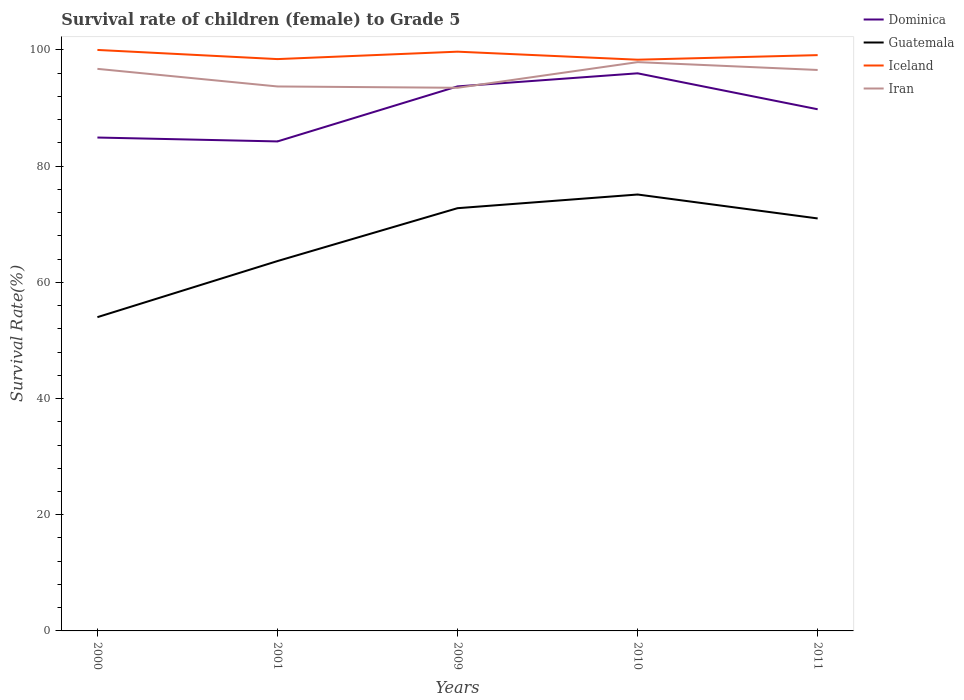Does the line corresponding to Guatemala intersect with the line corresponding to Iceland?
Keep it short and to the point. No. Across all years, what is the maximum survival rate of female children to grade 5 in Dominica?
Your answer should be very brief. 84.25. What is the total survival rate of female children to grade 5 in Iceland in the graph?
Offer a terse response. 0.3. What is the difference between the highest and the second highest survival rate of female children to grade 5 in Iceland?
Keep it short and to the point. 1.68. Is the survival rate of female children to grade 5 in Iran strictly greater than the survival rate of female children to grade 5 in Iceland over the years?
Your answer should be compact. Yes. What is the difference between two consecutive major ticks on the Y-axis?
Offer a terse response. 20. Does the graph contain any zero values?
Provide a succinct answer. No. Where does the legend appear in the graph?
Offer a very short reply. Top right. What is the title of the graph?
Your answer should be compact. Survival rate of children (female) to Grade 5. What is the label or title of the Y-axis?
Your response must be concise. Survival Rate(%). What is the Survival Rate(%) of Dominica in 2000?
Your answer should be very brief. 84.92. What is the Survival Rate(%) of Guatemala in 2000?
Your response must be concise. 54. What is the Survival Rate(%) in Iran in 2000?
Your response must be concise. 96.74. What is the Survival Rate(%) in Dominica in 2001?
Your answer should be very brief. 84.25. What is the Survival Rate(%) in Guatemala in 2001?
Keep it short and to the point. 63.66. What is the Survival Rate(%) in Iceland in 2001?
Your response must be concise. 98.42. What is the Survival Rate(%) in Iran in 2001?
Your answer should be very brief. 93.71. What is the Survival Rate(%) of Dominica in 2009?
Offer a terse response. 93.72. What is the Survival Rate(%) of Guatemala in 2009?
Make the answer very short. 72.76. What is the Survival Rate(%) of Iceland in 2009?
Ensure brevity in your answer.  99.7. What is the Survival Rate(%) in Iran in 2009?
Provide a short and direct response. 93.49. What is the Survival Rate(%) in Dominica in 2010?
Your response must be concise. 95.98. What is the Survival Rate(%) of Guatemala in 2010?
Offer a very short reply. 75.12. What is the Survival Rate(%) of Iceland in 2010?
Offer a very short reply. 98.32. What is the Survival Rate(%) in Iran in 2010?
Offer a terse response. 97.9. What is the Survival Rate(%) in Dominica in 2011?
Provide a short and direct response. 89.79. What is the Survival Rate(%) of Guatemala in 2011?
Keep it short and to the point. 71. What is the Survival Rate(%) of Iceland in 2011?
Ensure brevity in your answer.  99.11. What is the Survival Rate(%) in Iran in 2011?
Offer a terse response. 96.55. Across all years, what is the maximum Survival Rate(%) in Dominica?
Offer a very short reply. 95.98. Across all years, what is the maximum Survival Rate(%) of Guatemala?
Give a very brief answer. 75.12. Across all years, what is the maximum Survival Rate(%) of Iran?
Ensure brevity in your answer.  97.9. Across all years, what is the minimum Survival Rate(%) of Dominica?
Give a very brief answer. 84.25. Across all years, what is the minimum Survival Rate(%) of Guatemala?
Keep it short and to the point. 54. Across all years, what is the minimum Survival Rate(%) of Iceland?
Your answer should be very brief. 98.32. Across all years, what is the minimum Survival Rate(%) of Iran?
Give a very brief answer. 93.49. What is the total Survival Rate(%) in Dominica in the graph?
Provide a succinct answer. 448.66. What is the total Survival Rate(%) of Guatemala in the graph?
Your answer should be compact. 336.54. What is the total Survival Rate(%) in Iceland in the graph?
Ensure brevity in your answer.  495.55. What is the total Survival Rate(%) in Iran in the graph?
Keep it short and to the point. 478.4. What is the difference between the Survival Rate(%) in Dominica in 2000 and that in 2001?
Provide a succinct answer. 0.67. What is the difference between the Survival Rate(%) in Guatemala in 2000 and that in 2001?
Your response must be concise. -9.66. What is the difference between the Survival Rate(%) in Iceland in 2000 and that in 2001?
Keep it short and to the point. 1.58. What is the difference between the Survival Rate(%) of Iran in 2000 and that in 2001?
Offer a terse response. 3.03. What is the difference between the Survival Rate(%) in Dominica in 2000 and that in 2009?
Provide a succinct answer. -8.8. What is the difference between the Survival Rate(%) in Guatemala in 2000 and that in 2009?
Give a very brief answer. -18.76. What is the difference between the Survival Rate(%) in Iceland in 2000 and that in 2009?
Your answer should be very brief. 0.3. What is the difference between the Survival Rate(%) in Iran in 2000 and that in 2009?
Provide a succinct answer. 3.26. What is the difference between the Survival Rate(%) of Dominica in 2000 and that in 2010?
Provide a short and direct response. -11.05. What is the difference between the Survival Rate(%) of Guatemala in 2000 and that in 2010?
Your response must be concise. -21.11. What is the difference between the Survival Rate(%) of Iceland in 2000 and that in 2010?
Your answer should be compact. 1.68. What is the difference between the Survival Rate(%) of Iran in 2000 and that in 2010?
Offer a very short reply. -1.16. What is the difference between the Survival Rate(%) of Dominica in 2000 and that in 2011?
Ensure brevity in your answer.  -4.86. What is the difference between the Survival Rate(%) in Guatemala in 2000 and that in 2011?
Provide a succinct answer. -16.99. What is the difference between the Survival Rate(%) of Iceland in 2000 and that in 2011?
Ensure brevity in your answer.  0.89. What is the difference between the Survival Rate(%) of Iran in 2000 and that in 2011?
Provide a succinct answer. 0.19. What is the difference between the Survival Rate(%) of Dominica in 2001 and that in 2009?
Your response must be concise. -9.47. What is the difference between the Survival Rate(%) of Guatemala in 2001 and that in 2009?
Offer a very short reply. -9.1. What is the difference between the Survival Rate(%) of Iceland in 2001 and that in 2009?
Offer a very short reply. -1.28. What is the difference between the Survival Rate(%) of Iran in 2001 and that in 2009?
Make the answer very short. 0.23. What is the difference between the Survival Rate(%) in Dominica in 2001 and that in 2010?
Your answer should be very brief. -11.72. What is the difference between the Survival Rate(%) of Guatemala in 2001 and that in 2010?
Ensure brevity in your answer.  -11.45. What is the difference between the Survival Rate(%) in Iceland in 2001 and that in 2010?
Keep it short and to the point. 0.1. What is the difference between the Survival Rate(%) in Iran in 2001 and that in 2010?
Your answer should be very brief. -4.19. What is the difference between the Survival Rate(%) in Dominica in 2001 and that in 2011?
Provide a succinct answer. -5.54. What is the difference between the Survival Rate(%) in Guatemala in 2001 and that in 2011?
Provide a succinct answer. -7.34. What is the difference between the Survival Rate(%) of Iceland in 2001 and that in 2011?
Provide a succinct answer. -0.68. What is the difference between the Survival Rate(%) in Iran in 2001 and that in 2011?
Provide a short and direct response. -2.84. What is the difference between the Survival Rate(%) of Dominica in 2009 and that in 2010?
Ensure brevity in your answer.  -2.25. What is the difference between the Survival Rate(%) of Guatemala in 2009 and that in 2010?
Your answer should be compact. -2.35. What is the difference between the Survival Rate(%) in Iceland in 2009 and that in 2010?
Give a very brief answer. 1.38. What is the difference between the Survival Rate(%) in Iran in 2009 and that in 2010?
Provide a short and direct response. -4.42. What is the difference between the Survival Rate(%) in Dominica in 2009 and that in 2011?
Make the answer very short. 3.94. What is the difference between the Survival Rate(%) in Guatemala in 2009 and that in 2011?
Ensure brevity in your answer.  1.77. What is the difference between the Survival Rate(%) of Iceland in 2009 and that in 2011?
Offer a very short reply. 0.6. What is the difference between the Survival Rate(%) of Iran in 2009 and that in 2011?
Offer a very short reply. -3.07. What is the difference between the Survival Rate(%) of Dominica in 2010 and that in 2011?
Make the answer very short. 6.19. What is the difference between the Survival Rate(%) in Guatemala in 2010 and that in 2011?
Your answer should be compact. 4.12. What is the difference between the Survival Rate(%) in Iceland in 2010 and that in 2011?
Your answer should be compact. -0.79. What is the difference between the Survival Rate(%) of Iran in 2010 and that in 2011?
Keep it short and to the point. 1.35. What is the difference between the Survival Rate(%) in Dominica in 2000 and the Survival Rate(%) in Guatemala in 2001?
Give a very brief answer. 21.26. What is the difference between the Survival Rate(%) of Dominica in 2000 and the Survival Rate(%) of Iceland in 2001?
Provide a short and direct response. -13.5. What is the difference between the Survival Rate(%) of Dominica in 2000 and the Survival Rate(%) of Iran in 2001?
Make the answer very short. -8.79. What is the difference between the Survival Rate(%) in Guatemala in 2000 and the Survival Rate(%) in Iceland in 2001?
Offer a very short reply. -44.42. What is the difference between the Survival Rate(%) in Guatemala in 2000 and the Survival Rate(%) in Iran in 2001?
Your answer should be compact. -39.71. What is the difference between the Survival Rate(%) in Iceland in 2000 and the Survival Rate(%) in Iran in 2001?
Provide a succinct answer. 6.29. What is the difference between the Survival Rate(%) in Dominica in 2000 and the Survival Rate(%) in Guatemala in 2009?
Your answer should be very brief. 12.16. What is the difference between the Survival Rate(%) in Dominica in 2000 and the Survival Rate(%) in Iceland in 2009?
Keep it short and to the point. -14.78. What is the difference between the Survival Rate(%) in Dominica in 2000 and the Survival Rate(%) in Iran in 2009?
Make the answer very short. -8.56. What is the difference between the Survival Rate(%) in Guatemala in 2000 and the Survival Rate(%) in Iceland in 2009?
Provide a short and direct response. -45.7. What is the difference between the Survival Rate(%) in Guatemala in 2000 and the Survival Rate(%) in Iran in 2009?
Offer a terse response. -39.48. What is the difference between the Survival Rate(%) in Iceland in 2000 and the Survival Rate(%) in Iran in 2009?
Give a very brief answer. 6.51. What is the difference between the Survival Rate(%) of Dominica in 2000 and the Survival Rate(%) of Guatemala in 2010?
Make the answer very short. 9.81. What is the difference between the Survival Rate(%) of Dominica in 2000 and the Survival Rate(%) of Iceland in 2010?
Your response must be concise. -13.39. What is the difference between the Survival Rate(%) of Dominica in 2000 and the Survival Rate(%) of Iran in 2010?
Keep it short and to the point. -12.98. What is the difference between the Survival Rate(%) of Guatemala in 2000 and the Survival Rate(%) of Iceland in 2010?
Your answer should be very brief. -44.31. What is the difference between the Survival Rate(%) of Guatemala in 2000 and the Survival Rate(%) of Iran in 2010?
Keep it short and to the point. -43.9. What is the difference between the Survival Rate(%) of Iceland in 2000 and the Survival Rate(%) of Iran in 2010?
Offer a very short reply. 2.1. What is the difference between the Survival Rate(%) of Dominica in 2000 and the Survival Rate(%) of Guatemala in 2011?
Your response must be concise. 13.93. What is the difference between the Survival Rate(%) in Dominica in 2000 and the Survival Rate(%) in Iceland in 2011?
Ensure brevity in your answer.  -14.18. What is the difference between the Survival Rate(%) of Dominica in 2000 and the Survival Rate(%) of Iran in 2011?
Ensure brevity in your answer.  -11.63. What is the difference between the Survival Rate(%) of Guatemala in 2000 and the Survival Rate(%) of Iceland in 2011?
Keep it short and to the point. -45.1. What is the difference between the Survival Rate(%) in Guatemala in 2000 and the Survival Rate(%) in Iran in 2011?
Your answer should be compact. -42.55. What is the difference between the Survival Rate(%) of Iceland in 2000 and the Survival Rate(%) of Iran in 2011?
Ensure brevity in your answer.  3.45. What is the difference between the Survival Rate(%) in Dominica in 2001 and the Survival Rate(%) in Guatemala in 2009?
Make the answer very short. 11.49. What is the difference between the Survival Rate(%) in Dominica in 2001 and the Survival Rate(%) in Iceland in 2009?
Offer a terse response. -15.45. What is the difference between the Survival Rate(%) of Dominica in 2001 and the Survival Rate(%) of Iran in 2009?
Give a very brief answer. -9.23. What is the difference between the Survival Rate(%) in Guatemala in 2001 and the Survival Rate(%) in Iceland in 2009?
Provide a succinct answer. -36.04. What is the difference between the Survival Rate(%) in Guatemala in 2001 and the Survival Rate(%) in Iran in 2009?
Your response must be concise. -29.82. What is the difference between the Survival Rate(%) of Iceland in 2001 and the Survival Rate(%) of Iran in 2009?
Offer a terse response. 4.94. What is the difference between the Survival Rate(%) of Dominica in 2001 and the Survival Rate(%) of Guatemala in 2010?
Ensure brevity in your answer.  9.14. What is the difference between the Survival Rate(%) in Dominica in 2001 and the Survival Rate(%) in Iceland in 2010?
Keep it short and to the point. -14.07. What is the difference between the Survival Rate(%) in Dominica in 2001 and the Survival Rate(%) in Iran in 2010?
Give a very brief answer. -13.65. What is the difference between the Survival Rate(%) in Guatemala in 2001 and the Survival Rate(%) in Iceland in 2010?
Offer a very short reply. -34.66. What is the difference between the Survival Rate(%) of Guatemala in 2001 and the Survival Rate(%) of Iran in 2010?
Give a very brief answer. -34.24. What is the difference between the Survival Rate(%) in Iceland in 2001 and the Survival Rate(%) in Iran in 2010?
Your response must be concise. 0.52. What is the difference between the Survival Rate(%) of Dominica in 2001 and the Survival Rate(%) of Guatemala in 2011?
Make the answer very short. 13.26. What is the difference between the Survival Rate(%) of Dominica in 2001 and the Survival Rate(%) of Iceland in 2011?
Your response must be concise. -14.85. What is the difference between the Survival Rate(%) of Dominica in 2001 and the Survival Rate(%) of Iran in 2011?
Ensure brevity in your answer.  -12.3. What is the difference between the Survival Rate(%) of Guatemala in 2001 and the Survival Rate(%) of Iceland in 2011?
Keep it short and to the point. -35.45. What is the difference between the Survival Rate(%) of Guatemala in 2001 and the Survival Rate(%) of Iran in 2011?
Your response must be concise. -32.89. What is the difference between the Survival Rate(%) in Iceland in 2001 and the Survival Rate(%) in Iran in 2011?
Ensure brevity in your answer.  1.87. What is the difference between the Survival Rate(%) of Dominica in 2009 and the Survival Rate(%) of Guatemala in 2010?
Give a very brief answer. 18.61. What is the difference between the Survival Rate(%) of Dominica in 2009 and the Survival Rate(%) of Iceland in 2010?
Make the answer very short. -4.6. What is the difference between the Survival Rate(%) in Dominica in 2009 and the Survival Rate(%) in Iran in 2010?
Your answer should be very brief. -4.18. What is the difference between the Survival Rate(%) in Guatemala in 2009 and the Survival Rate(%) in Iceland in 2010?
Provide a succinct answer. -25.56. What is the difference between the Survival Rate(%) in Guatemala in 2009 and the Survival Rate(%) in Iran in 2010?
Keep it short and to the point. -25.14. What is the difference between the Survival Rate(%) in Iceland in 2009 and the Survival Rate(%) in Iran in 2010?
Offer a very short reply. 1.8. What is the difference between the Survival Rate(%) of Dominica in 2009 and the Survival Rate(%) of Guatemala in 2011?
Give a very brief answer. 22.73. What is the difference between the Survival Rate(%) of Dominica in 2009 and the Survival Rate(%) of Iceland in 2011?
Offer a very short reply. -5.38. What is the difference between the Survival Rate(%) in Dominica in 2009 and the Survival Rate(%) in Iran in 2011?
Offer a very short reply. -2.83. What is the difference between the Survival Rate(%) in Guatemala in 2009 and the Survival Rate(%) in Iceland in 2011?
Offer a very short reply. -26.34. What is the difference between the Survival Rate(%) in Guatemala in 2009 and the Survival Rate(%) in Iran in 2011?
Offer a very short reply. -23.79. What is the difference between the Survival Rate(%) in Iceland in 2009 and the Survival Rate(%) in Iran in 2011?
Give a very brief answer. 3.15. What is the difference between the Survival Rate(%) in Dominica in 2010 and the Survival Rate(%) in Guatemala in 2011?
Ensure brevity in your answer.  24.98. What is the difference between the Survival Rate(%) in Dominica in 2010 and the Survival Rate(%) in Iceland in 2011?
Offer a very short reply. -3.13. What is the difference between the Survival Rate(%) of Dominica in 2010 and the Survival Rate(%) of Iran in 2011?
Your answer should be compact. -0.58. What is the difference between the Survival Rate(%) of Guatemala in 2010 and the Survival Rate(%) of Iceland in 2011?
Give a very brief answer. -23.99. What is the difference between the Survival Rate(%) of Guatemala in 2010 and the Survival Rate(%) of Iran in 2011?
Your answer should be very brief. -21.44. What is the difference between the Survival Rate(%) of Iceland in 2010 and the Survival Rate(%) of Iran in 2011?
Offer a terse response. 1.77. What is the average Survival Rate(%) in Dominica per year?
Make the answer very short. 89.73. What is the average Survival Rate(%) of Guatemala per year?
Ensure brevity in your answer.  67.31. What is the average Survival Rate(%) in Iceland per year?
Your answer should be very brief. 99.11. What is the average Survival Rate(%) in Iran per year?
Offer a very short reply. 95.68. In the year 2000, what is the difference between the Survival Rate(%) of Dominica and Survival Rate(%) of Guatemala?
Ensure brevity in your answer.  30.92. In the year 2000, what is the difference between the Survival Rate(%) in Dominica and Survival Rate(%) in Iceland?
Provide a succinct answer. -15.08. In the year 2000, what is the difference between the Survival Rate(%) in Dominica and Survival Rate(%) in Iran?
Your answer should be very brief. -11.82. In the year 2000, what is the difference between the Survival Rate(%) of Guatemala and Survival Rate(%) of Iceland?
Your answer should be compact. -46. In the year 2000, what is the difference between the Survival Rate(%) of Guatemala and Survival Rate(%) of Iran?
Keep it short and to the point. -42.74. In the year 2000, what is the difference between the Survival Rate(%) in Iceland and Survival Rate(%) in Iran?
Your response must be concise. 3.25. In the year 2001, what is the difference between the Survival Rate(%) in Dominica and Survival Rate(%) in Guatemala?
Provide a succinct answer. 20.59. In the year 2001, what is the difference between the Survival Rate(%) of Dominica and Survival Rate(%) of Iceland?
Provide a short and direct response. -14.17. In the year 2001, what is the difference between the Survival Rate(%) of Dominica and Survival Rate(%) of Iran?
Your response must be concise. -9.46. In the year 2001, what is the difference between the Survival Rate(%) in Guatemala and Survival Rate(%) in Iceland?
Keep it short and to the point. -34.76. In the year 2001, what is the difference between the Survival Rate(%) in Guatemala and Survival Rate(%) in Iran?
Keep it short and to the point. -30.05. In the year 2001, what is the difference between the Survival Rate(%) of Iceland and Survival Rate(%) of Iran?
Keep it short and to the point. 4.71. In the year 2009, what is the difference between the Survival Rate(%) in Dominica and Survival Rate(%) in Guatemala?
Provide a succinct answer. 20.96. In the year 2009, what is the difference between the Survival Rate(%) in Dominica and Survival Rate(%) in Iceland?
Keep it short and to the point. -5.98. In the year 2009, what is the difference between the Survival Rate(%) in Dominica and Survival Rate(%) in Iran?
Your answer should be compact. 0.24. In the year 2009, what is the difference between the Survival Rate(%) in Guatemala and Survival Rate(%) in Iceland?
Make the answer very short. -26.94. In the year 2009, what is the difference between the Survival Rate(%) of Guatemala and Survival Rate(%) of Iran?
Ensure brevity in your answer.  -20.72. In the year 2009, what is the difference between the Survival Rate(%) of Iceland and Survival Rate(%) of Iran?
Offer a very short reply. 6.22. In the year 2010, what is the difference between the Survival Rate(%) in Dominica and Survival Rate(%) in Guatemala?
Your response must be concise. 20.86. In the year 2010, what is the difference between the Survival Rate(%) in Dominica and Survival Rate(%) in Iceland?
Offer a terse response. -2.34. In the year 2010, what is the difference between the Survival Rate(%) of Dominica and Survival Rate(%) of Iran?
Keep it short and to the point. -1.93. In the year 2010, what is the difference between the Survival Rate(%) in Guatemala and Survival Rate(%) in Iceland?
Your response must be concise. -23.2. In the year 2010, what is the difference between the Survival Rate(%) of Guatemala and Survival Rate(%) of Iran?
Your answer should be very brief. -22.79. In the year 2010, what is the difference between the Survival Rate(%) in Iceland and Survival Rate(%) in Iran?
Provide a succinct answer. 0.42. In the year 2011, what is the difference between the Survival Rate(%) in Dominica and Survival Rate(%) in Guatemala?
Keep it short and to the point. 18.79. In the year 2011, what is the difference between the Survival Rate(%) of Dominica and Survival Rate(%) of Iceland?
Provide a succinct answer. -9.32. In the year 2011, what is the difference between the Survival Rate(%) of Dominica and Survival Rate(%) of Iran?
Provide a succinct answer. -6.76. In the year 2011, what is the difference between the Survival Rate(%) of Guatemala and Survival Rate(%) of Iceland?
Make the answer very short. -28.11. In the year 2011, what is the difference between the Survival Rate(%) in Guatemala and Survival Rate(%) in Iran?
Ensure brevity in your answer.  -25.56. In the year 2011, what is the difference between the Survival Rate(%) of Iceland and Survival Rate(%) of Iran?
Offer a very short reply. 2.55. What is the ratio of the Survival Rate(%) of Dominica in 2000 to that in 2001?
Offer a terse response. 1.01. What is the ratio of the Survival Rate(%) of Guatemala in 2000 to that in 2001?
Provide a short and direct response. 0.85. What is the ratio of the Survival Rate(%) of Iran in 2000 to that in 2001?
Your response must be concise. 1.03. What is the ratio of the Survival Rate(%) of Dominica in 2000 to that in 2009?
Offer a terse response. 0.91. What is the ratio of the Survival Rate(%) of Guatemala in 2000 to that in 2009?
Your answer should be very brief. 0.74. What is the ratio of the Survival Rate(%) of Iran in 2000 to that in 2009?
Offer a terse response. 1.03. What is the ratio of the Survival Rate(%) of Dominica in 2000 to that in 2010?
Ensure brevity in your answer.  0.88. What is the ratio of the Survival Rate(%) of Guatemala in 2000 to that in 2010?
Offer a very short reply. 0.72. What is the ratio of the Survival Rate(%) in Iceland in 2000 to that in 2010?
Your answer should be very brief. 1.02. What is the ratio of the Survival Rate(%) in Dominica in 2000 to that in 2011?
Provide a succinct answer. 0.95. What is the ratio of the Survival Rate(%) of Guatemala in 2000 to that in 2011?
Offer a very short reply. 0.76. What is the ratio of the Survival Rate(%) of Iceland in 2000 to that in 2011?
Provide a short and direct response. 1.01. What is the ratio of the Survival Rate(%) of Dominica in 2001 to that in 2009?
Your response must be concise. 0.9. What is the ratio of the Survival Rate(%) of Guatemala in 2001 to that in 2009?
Your answer should be very brief. 0.87. What is the ratio of the Survival Rate(%) in Iceland in 2001 to that in 2009?
Make the answer very short. 0.99. What is the ratio of the Survival Rate(%) of Iran in 2001 to that in 2009?
Give a very brief answer. 1. What is the ratio of the Survival Rate(%) of Dominica in 2001 to that in 2010?
Offer a very short reply. 0.88. What is the ratio of the Survival Rate(%) of Guatemala in 2001 to that in 2010?
Your answer should be compact. 0.85. What is the ratio of the Survival Rate(%) of Iceland in 2001 to that in 2010?
Your answer should be very brief. 1. What is the ratio of the Survival Rate(%) of Iran in 2001 to that in 2010?
Your answer should be compact. 0.96. What is the ratio of the Survival Rate(%) in Dominica in 2001 to that in 2011?
Give a very brief answer. 0.94. What is the ratio of the Survival Rate(%) in Guatemala in 2001 to that in 2011?
Make the answer very short. 0.9. What is the ratio of the Survival Rate(%) of Iceland in 2001 to that in 2011?
Your answer should be compact. 0.99. What is the ratio of the Survival Rate(%) in Iran in 2001 to that in 2011?
Make the answer very short. 0.97. What is the ratio of the Survival Rate(%) of Dominica in 2009 to that in 2010?
Give a very brief answer. 0.98. What is the ratio of the Survival Rate(%) in Guatemala in 2009 to that in 2010?
Provide a short and direct response. 0.97. What is the ratio of the Survival Rate(%) of Iceland in 2009 to that in 2010?
Your response must be concise. 1.01. What is the ratio of the Survival Rate(%) in Iran in 2009 to that in 2010?
Your answer should be compact. 0.95. What is the ratio of the Survival Rate(%) in Dominica in 2009 to that in 2011?
Provide a short and direct response. 1.04. What is the ratio of the Survival Rate(%) in Guatemala in 2009 to that in 2011?
Make the answer very short. 1.02. What is the ratio of the Survival Rate(%) of Iran in 2009 to that in 2011?
Your response must be concise. 0.97. What is the ratio of the Survival Rate(%) of Dominica in 2010 to that in 2011?
Your answer should be very brief. 1.07. What is the ratio of the Survival Rate(%) of Guatemala in 2010 to that in 2011?
Offer a very short reply. 1.06. What is the difference between the highest and the second highest Survival Rate(%) in Dominica?
Ensure brevity in your answer.  2.25. What is the difference between the highest and the second highest Survival Rate(%) of Guatemala?
Ensure brevity in your answer.  2.35. What is the difference between the highest and the second highest Survival Rate(%) of Iceland?
Your answer should be compact. 0.3. What is the difference between the highest and the second highest Survival Rate(%) of Iran?
Offer a very short reply. 1.16. What is the difference between the highest and the lowest Survival Rate(%) of Dominica?
Give a very brief answer. 11.72. What is the difference between the highest and the lowest Survival Rate(%) in Guatemala?
Your answer should be very brief. 21.11. What is the difference between the highest and the lowest Survival Rate(%) in Iceland?
Your answer should be very brief. 1.68. What is the difference between the highest and the lowest Survival Rate(%) of Iran?
Ensure brevity in your answer.  4.42. 